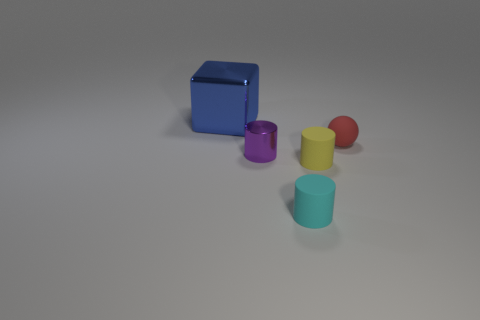There is a tiny thing that is both behind the tiny yellow cylinder and on the left side of the yellow matte object; what is its shape?
Offer a terse response. Cylinder. Is there anything else that is the same size as the block?
Provide a succinct answer. No. There is a metal object that is on the right side of the metal object that is behind the small ball; what is its color?
Your answer should be very brief. Purple. The tiny object to the left of the tiny cyan matte thing that is in front of the small purple metallic cylinder behind the yellow rubber cylinder is what shape?
Your response must be concise. Cylinder. There is a object that is both behind the small metal thing and to the left of the cyan cylinder; what is its size?
Make the answer very short. Large. What number of matte spheres are the same color as the small metal cylinder?
Offer a terse response. 0. What material is the small yellow cylinder?
Offer a terse response. Rubber. Do the object that is behind the small red matte thing and the tiny cyan object have the same material?
Your response must be concise. No. What shape is the shiny object in front of the small ball?
Provide a short and direct response. Cylinder. What is the material of the yellow thing that is the same size as the red ball?
Your answer should be very brief. Rubber. 